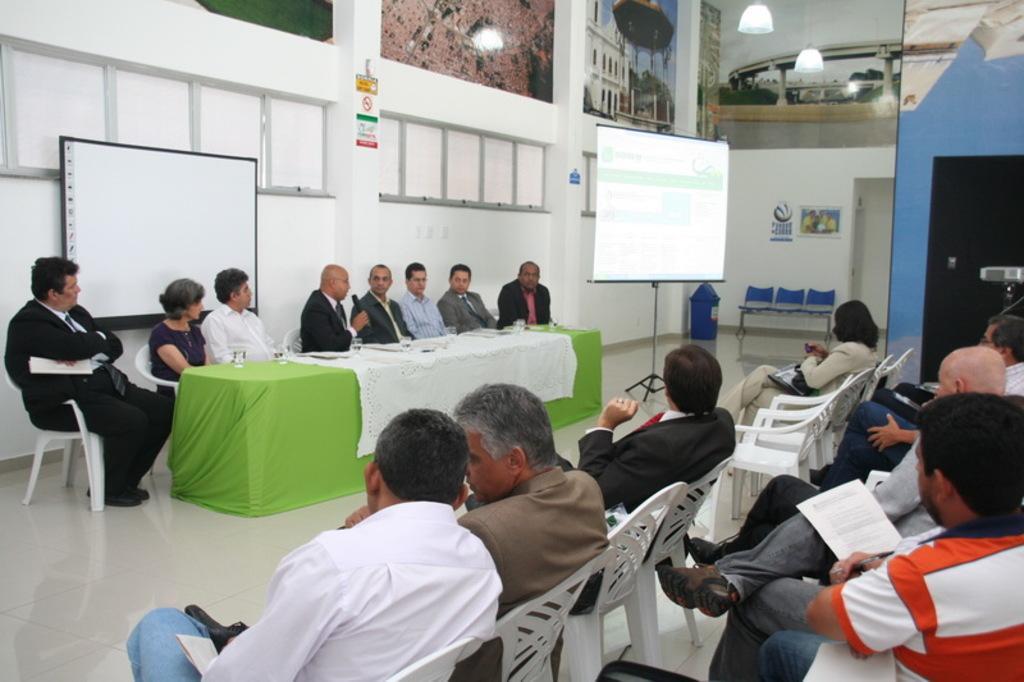Could you give a brief overview of what you see in this image? In this picture we can see some people sitting on the chairs and giving a speech. Behind there is a projector screen and white wall. In the front there are some people sitting on the chair and listening to them. On the top we can see the photo frame and hanging lights. 